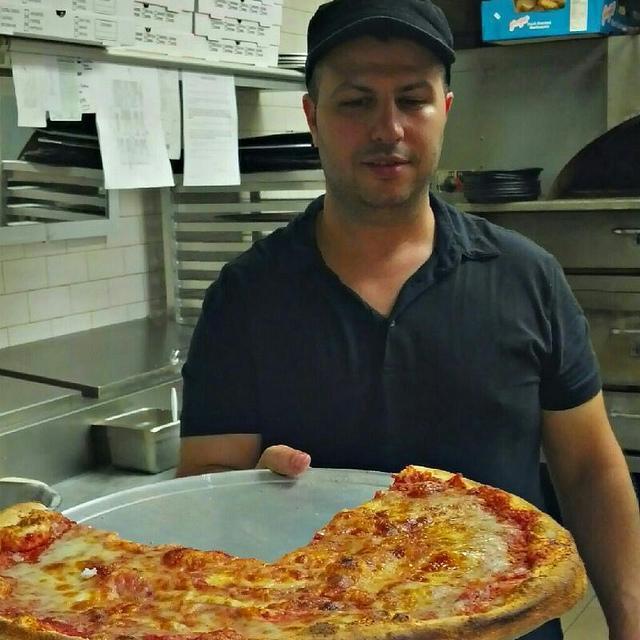Is the caption "The person is close to the pizza." a true representation of the image?
Answer yes or no. Yes. 